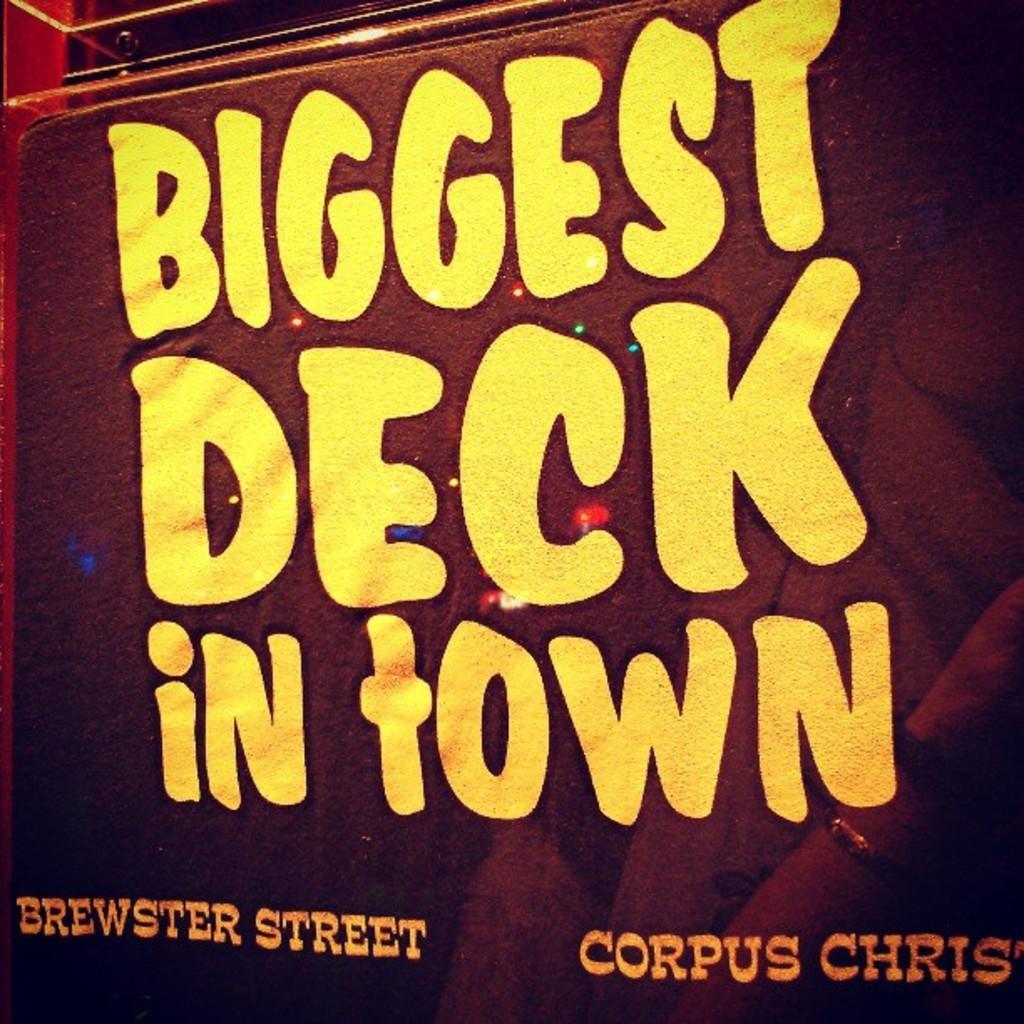Could you give a brief overview of what you see in this image? In this picture we can see a poster, there is some text here. 